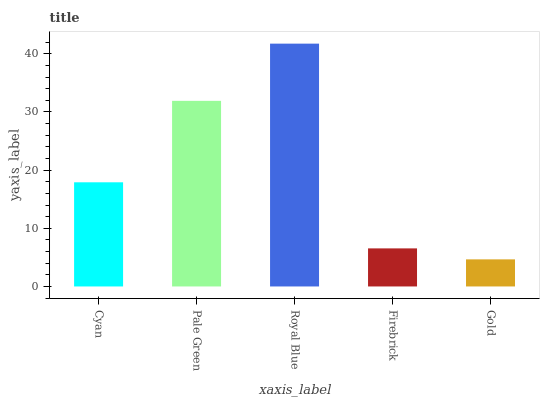Is Pale Green the minimum?
Answer yes or no. No. Is Pale Green the maximum?
Answer yes or no. No. Is Pale Green greater than Cyan?
Answer yes or no. Yes. Is Cyan less than Pale Green?
Answer yes or no. Yes. Is Cyan greater than Pale Green?
Answer yes or no. No. Is Pale Green less than Cyan?
Answer yes or no. No. Is Cyan the high median?
Answer yes or no. Yes. Is Cyan the low median?
Answer yes or no. Yes. Is Pale Green the high median?
Answer yes or no. No. Is Pale Green the low median?
Answer yes or no. No. 